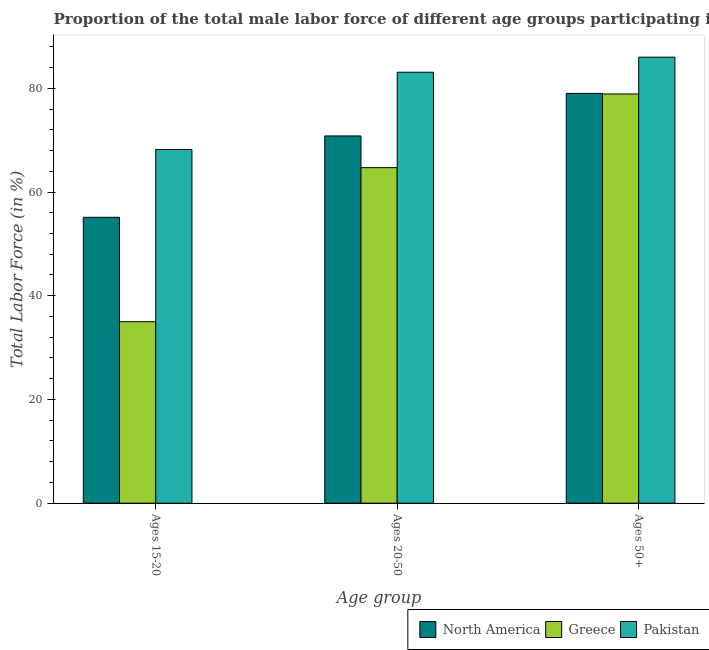How many different coloured bars are there?
Make the answer very short. 3. Are the number of bars on each tick of the X-axis equal?
Provide a short and direct response. Yes. What is the label of the 2nd group of bars from the left?
Ensure brevity in your answer.  Ages 20-50. What is the percentage of male labor force within the age group 15-20 in North America?
Keep it short and to the point. 55.13. Across all countries, what is the maximum percentage of male labor force within the age group 20-50?
Your response must be concise. 83.1. Across all countries, what is the minimum percentage of male labor force above age 50?
Your response must be concise. 78.9. In which country was the percentage of male labor force within the age group 20-50 maximum?
Your response must be concise. Pakistan. What is the total percentage of male labor force above age 50 in the graph?
Give a very brief answer. 243.92. What is the difference between the percentage of male labor force above age 50 in Greece and that in North America?
Offer a very short reply. -0.12. What is the difference between the percentage of male labor force above age 50 in North America and the percentage of male labor force within the age group 15-20 in Pakistan?
Your answer should be very brief. 10.82. What is the average percentage of male labor force within the age group 15-20 per country?
Your response must be concise. 52.78. What is the difference between the percentage of male labor force within the age group 20-50 and percentage of male labor force within the age group 15-20 in North America?
Your answer should be very brief. 15.69. In how many countries, is the percentage of male labor force above age 50 greater than 40 %?
Offer a terse response. 3. What is the ratio of the percentage of male labor force within the age group 20-50 in North America to that in Pakistan?
Your response must be concise. 0.85. Is the percentage of male labor force within the age group 20-50 in Greece less than that in Pakistan?
Your response must be concise. Yes. What is the difference between the highest and the second highest percentage of male labor force within the age group 20-50?
Give a very brief answer. 12.29. What is the difference between the highest and the lowest percentage of male labor force within the age group 15-20?
Give a very brief answer. 33.2. Is the sum of the percentage of male labor force within the age group 15-20 in Greece and Pakistan greater than the maximum percentage of male labor force above age 50 across all countries?
Provide a succinct answer. Yes. What does the 2nd bar from the left in Ages 50+ represents?
Keep it short and to the point. Greece. What does the 2nd bar from the right in Ages 50+ represents?
Offer a terse response. Greece. Is it the case that in every country, the sum of the percentage of male labor force within the age group 15-20 and percentage of male labor force within the age group 20-50 is greater than the percentage of male labor force above age 50?
Offer a very short reply. Yes. How many bars are there?
Your answer should be very brief. 9. What is the difference between two consecutive major ticks on the Y-axis?
Make the answer very short. 20. Does the graph contain any zero values?
Your answer should be compact. No. Does the graph contain grids?
Provide a short and direct response. No. Where does the legend appear in the graph?
Provide a succinct answer. Bottom right. How are the legend labels stacked?
Provide a short and direct response. Horizontal. What is the title of the graph?
Give a very brief answer. Proportion of the total male labor force of different age groups participating in production in 2009. Does "Somalia" appear as one of the legend labels in the graph?
Offer a terse response. No. What is the label or title of the X-axis?
Your response must be concise. Age group. What is the Total Labor Force (in %) in North America in Ages 15-20?
Provide a succinct answer. 55.13. What is the Total Labor Force (in %) of Greece in Ages 15-20?
Give a very brief answer. 35. What is the Total Labor Force (in %) of Pakistan in Ages 15-20?
Offer a terse response. 68.2. What is the Total Labor Force (in %) of North America in Ages 20-50?
Your answer should be compact. 70.81. What is the Total Labor Force (in %) of Greece in Ages 20-50?
Provide a short and direct response. 64.7. What is the Total Labor Force (in %) in Pakistan in Ages 20-50?
Provide a succinct answer. 83.1. What is the Total Labor Force (in %) of North America in Ages 50+?
Your answer should be very brief. 79.02. What is the Total Labor Force (in %) in Greece in Ages 50+?
Provide a succinct answer. 78.9. Across all Age group, what is the maximum Total Labor Force (in %) of North America?
Make the answer very short. 79.02. Across all Age group, what is the maximum Total Labor Force (in %) in Greece?
Your response must be concise. 78.9. Across all Age group, what is the minimum Total Labor Force (in %) of North America?
Provide a succinct answer. 55.13. Across all Age group, what is the minimum Total Labor Force (in %) of Greece?
Ensure brevity in your answer.  35. Across all Age group, what is the minimum Total Labor Force (in %) in Pakistan?
Provide a short and direct response. 68.2. What is the total Total Labor Force (in %) of North America in the graph?
Provide a succinct answer. 204.95. What is the total Total Labor Force (in %) of Greece in the graph?
Provide a succinct answer. 178.6. What is the total Total Labor Force (in %) in Pakistan in the graph?
Your answer should be very brief. 237.3. What is the difference between the Total Labor Force (in %) of North America in Ages 15-20 and that in Ages 20-50?
Offer a terse response. -15.69. What is the difference between the Total Labor Force (in %) in Greece in Ages 15-20 and that in Ages 20-50?
Ensure brevity in your answer.  -29.7. What is the difference between the Total Labor Force (in %) in Pakistan in Ages 15-20 and that in Ages 20-50?
Your answer should be compact. -14.9. What is the difference between the Total Labor Force (in %) of North America in Ages 15-20 and that in Ages 50+?
Your response must be concise. -23.89. What is the difference between the Total Labor Force (in %) of Greece in Ages 15-20 and that in Ages 50+?
Keep it short and to the point. -43.9. What is the difference between the Total Labor Force (in %) of Pakistan in Ages 15-20 and that in Ages 50+?
Provide a succinct answer. -17.8. What is the difference between the Total Labor Force (in %) in North America in Ages 20-50 and that in Ages 50+?
Keep it short and to the point. -8.2. What is the difference between the Total Labor Force (in %) of North America in Ages 15-20 and the Total Labor Force (in %) of Greece in Ages 20-50?
Your response must be concise. -9.57. What is the difference between the Total Labor Force (in %) in North America in Ages 15-20 and the Total Labor Force (in %) in Pakistan in Ages 20-50?
Keep it short and to the point. -27.97. What is the difference between the Total Labor Force (in %) of Greece in Ages 15-20 and the Total Labor Force (in %) of Pakistan in Ages 20-50?
Offer a very short reply. -48.1. What is the difference between the Total Labor Force (in %) of North America in Ages 15-20 and the Total Labor Force (in %) of Greece in Ages 50+?
Your answer should be compact. -23.77. What is the difference between the Total Labor Force (in %) of North America in Ages 15-20 and the Total Labor Force (in %) of Pakistan in Ages 50+?
Provide a succinct answer. -30.87. What is the difference between the Total Labor Force (in %) in Greece in Ages 15-20 and the Total Labor Force (in %) in Pakistan in Ages 50+?
Your answer should be compact. -51. What is the difference between the Total Labor Force (in %) of North America in Ages 20-50 and the Total Labor Force (in %) of Greece in Ages 50+?
Your response must be concise. -8.09. What is the difference between the Total Labor Force (in %) in North America in Ages 20-50 and the Total Labor Force (in %) in Pakistan in Ages 50+?
Your answer should be compact. -15.19. What is the difference between the Total Labor Force (in %) of Greece in Ages 20-50 and the Total Labor Force (in %) of Pakistan in Ages 50+?
Offer a very short reply. -21.3. What is the average Total Labor Force (in %) of North America per Age group?
Your answer should be compact. 68.32. What is the average Total Labor Force (in %) in Greece per Age group?
Make the answer very short. 59.53. What is the average Total Labor Force (in %) of Pakistan per Age group?
Keep it short and to the point. 79.1. What is the difference between the Total Labor Force (in %) in North America and Total Labor Force (in %) in Greece in Ages 15-20?
Offer a very short reply. 20.13. What is the difference between the Total Labor Force (in %) of North America and Total Labor Force (in %) of Pakistan in Ages 15-20?
Offer a terse response. -13.07. What is the difference between the Total Labor Force (in %) of Greece and Total Labor Force (in %) of Pakistan in Ages 15-20?
Offer a very short reply. -33.2. What is the difference between the Total Labor Force (in %) in North America and Total Labor Force (in %) in Greece in Ages 20-50?
Make the answer very short. 6.11. What is the difference between the Total Labor Force (in %) of North America and Total Labor Force (in %) of Pakistan in Ages 20-50?
Provide a succinct answer. -12.29. What is the difference between the Total Labor Force (in %) of Greece and Total Labor Force (in %) of Pakistan in Ages 20-50?
Keep it short and to the point. -18.4. What is the difference between the Total Labor Force (in %) in North America and Total Labor Force (in %) in Greece in Ages 50+?
Your response must be concise. 0.12. What is the difference between the Total Labor Force (in %) in North America and Total Labor Force (in %) in Pakistan in Ages 50+?
Your response must be concise. -6.98. What is the difference between the Total Labor Force (in %) in Greece and Total Labor Force (in %) in Pakistan in Ages 50+?
Ensure brevity in your answer.  -7.1. What is the ratio of the Total Labor Force (in %) of North America in Ages 15-20 to that in Ages 20-50?
Your response must be concise. 0.78. What is the ratio of the Total Labor Force (in %) in Greece in Ages 15-20 to that in Ages 20-50?
Provide a succinct answer. 0.54. What is the ratio of the Total Labor Force (in %) in Pakistan in Ages 15-20 to that in Ages 20-50?
Give a very brief answer. 0.82. What is the ratio of the Total Labor Force (in %) of North America in Ages 15-20 to that in Ages 50+?
Provide a short and direct response. 0.7. What is the ratio of the Total Labor Force (in %) of Greece in Ages 15-20 to that in Ages 50+?
Your response must be concise. 0.44. What is the ratio of the Total Labor Force (in %) of Pakistan in Ages 15-20 to that in Ages 50+?
Give a very brief answer. 0.79. What is the ratio of the Total Labor Force (in %) in North America in Ages 20-50 to that in Ages 50+?
Keep it short and to the point. 0.9. What is the ratio of the Total Labor Force (in %) in Greece in Ages 20-50 to that in Ages 50+?
Ensure brevity in your answer.  0.82. What is the ratio of the Total Labor Force (in %) of Pakistan in Ages 20-50 to that in Ages 50+?
Ensure brevity in your answer.  0.97. What is the difference between the highest and the second highest Total Labor Force (in %) in North America?
Your answer should be compact. 8.2. What is the difference between the highest and the second highest Total Labor Force (in %) of Greece?
Provide a short and direct response. 14.2. What is the difference between the highest and the lowest Total Labor Force (in %) in North America?
Your answer should be compact. 23.89. What is the difference between the highest and the lowest Total Labor Force (in %) in Greece?
Make the answer very short. 43.9. What is the difference between the highest and the lowest Total Labor Force (in %) of Pakistan?
Keep it short and to the point. 17.8. 